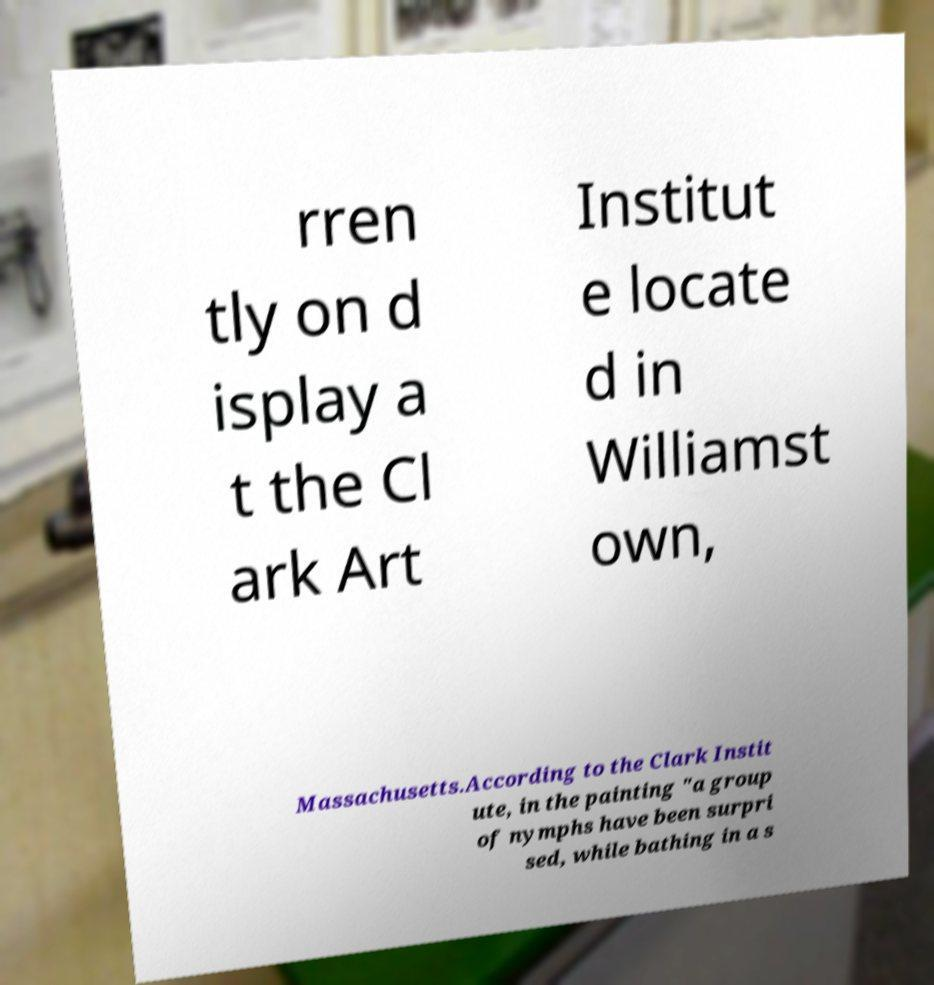Please read and relay the text visible in this image. What does it say? rren tly on d isplay a t the Cl ark Art Institut e locate d in Williamst own, Massachusetts.According to the Clark Instit ute, in the painting "a group of nymphs have been surpri sed, while bathing in a s 